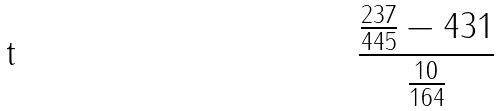Convert formula to latex. <formula><loc_0><loc_0><loc_500><loc_500>\frac { \frac { 2 3 7 } { 4 4 5 } - 4 3 1 } { \frac { 1 0 } { 1 6 4 } }</formula> 